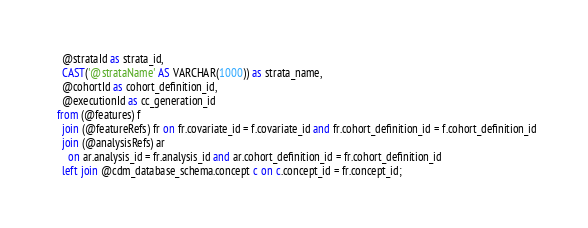Convert code to text. <code><loc_0><loc_0><loc_500><loc_500><_SQL_>    @strataId as strata_id,
    CAST('@strataName' AS VARCHAR(1000)) as strata_name,
    @cohortId as cohort_definition_id,
    @executionId as cc_generation_id
  from (@features) f
    join (@featureRefs) fr on fr.covariate_id = f.covariate_id and fr.cohort_definition_id = f.cohort_definition_id
    join (@analysisRefs) ar
      on ar.analysis_id = fr.analysis_id and ar.cohort_definition_id = fr.cohort_definition_id
    left join @cdm_database_schema.concept c on c.concept_id = fr.concept_id;</code> 